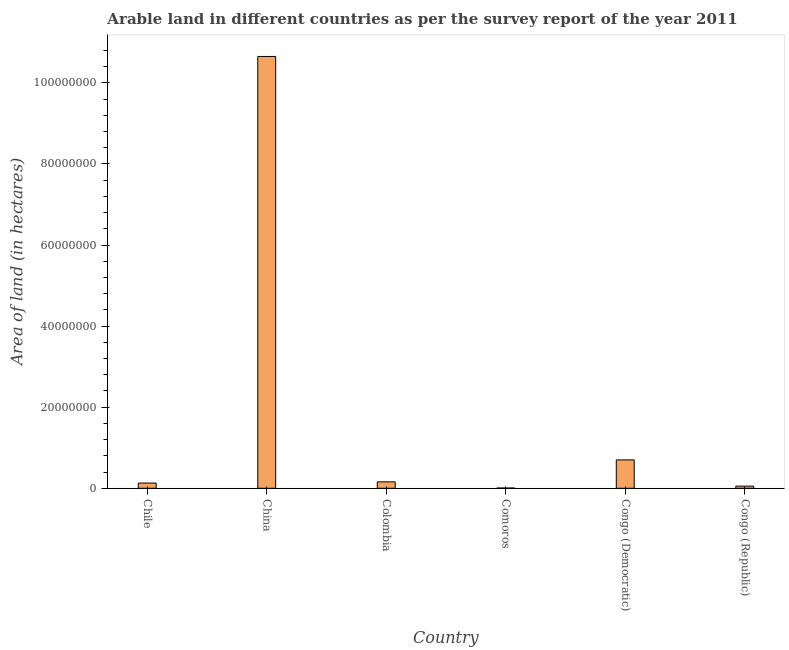Does the graph contain any zero values?
Give a very brief answer. No. What is the title of the graph?
Keep it short and to the point. Arable land in different countries as per the survey report of the year 2011. What is the label or title of the Y-axis?
Offer a very short reply. Area of land (in hectares). What is the area of land in China?
Give a very brief answer. 1.07e+08. Across all countries, what is the maximum area of land?
Offer a very short reply. 1.07e+08. Across all countries, what is the minimum area of land?
Keep it short and to the point. 6.50e+04. In which country was the area of land maximum?
Your answer should be very brief. China. In which country was the area of land minimum?
Your answer should be very brief. Comoros. What is the sum of the area of land?
Your answer should be compact. 1.17e+08. What is the difference between the area of land in Colombia and Congo (Democratic)?
Provide a short and direct response. -5.41e+06. What is the average area of land per country?
Offer a very short reply. 1.95e+07. What is the median area of land?
Ensure brevity in your answer.  1.44e+06. What is the ratio of the area of land in Chile to that in Congo (Republic)?
Your answer should be very brief. 2.43. What is the difference between the highest and the second highest area of land?
Keep it short and to the point. 9.95e+07. What is the difference between the highest and the lowest area of land?
Keep it short and to the point. 1.06e+08. In how many countries, is the area of land greater than the average area of land taken over all countries?
Offer a very short reply. 1. Are all the bars in the graph horizontal?
Offer a terse response. No. How many countries are there in the graph?
Make the answer very short. 6. Are the values on the major ticks of Y-axis written in scientific E-notation?
Make the answer very short. No. What is the Area of land (in hectares) in Chile?
Give a very brief answer. 1.29e+06. What is the Area of land (in hectares) in China?
Offer a terse response. 1.07e+08. What is the Area of land (in hectares) in Colombia?
Your response must be concise. 1.59e+06. What is the Area of land (in hectares) in Comoros?
Offer a very short reply. 6.50e+04. What is the Area of land (in hectares) in Congo (Republic)?
Your answer should be compact. 5.30e+05. What is the difference between the Area of land (in hectares) in Chile and China?
Keep it short and to the point. -1.05e+08. What is the difference between the Area of land (in hectares) in Chile and Colombia?
Your response must be concise. -2.99e+05. What is the difference between the Area of land (in hectares) in Chile and Comoros?
Ensure brevity in your answer.  1.22e+06. What is the difference between the Area of land (in hectares) in Chile and Congo (Democratic)?
Your response must be concise. -5.71e+06. What is the difference between the Area of land (in hectares) in Chile and Congo (Republic)?
Offer a terse response. 7.57e+05. What is the difference between the Area of land (in hectares) in China and Colombia?
Keep it short and to the point. 1.05e+08. What is the difference between the Area of land (in hectares) in China and Comoros?
Your response must be concise. 1.06e+08. What is the difference between the Area of land (in hectares) in China and Congo (Democratic)?
Offer a terse response. 9.95e+07. What is the difference between the Area of land (in hectares) in China and Congo (Republic)?
Provide a succinct answer. 1.06e+08. What is the difference between the Area of land (in hectares) in Colombia and Comoros?
Offer a very short reply. 1.52e+06. What is the difference between the Area of land (in hectares) in Colombia and Congo (Democratic)?
Make the answer very short. -5.41e+06. What is the difference between the Area of land (in hectares) in Colombia and Congo (Republic)?
Your answer should be very brief. 1.06e+06. What is the difference between the Area of land (in hectares) in Comoros and Congo (Democratic)?
Provide a short and direct response. -6.94e+06. What is the difference between the Area of land (in hectares) in Comoros and Congo (Republic)?
Provide a succinct answer. -4.65e+05. What is the difference between the Area of land (in hectares) in Congo (Democratic) and Congo (Republic)?
Provide a short and direct response. 6.47e+06. What is the ratio of the Area of land (in hectares) in Chile to that in China?
Offer a terse response. 0.01. What is the ratio of the Area of land (in hectares) in Chile to that in Colombia?
Provide a short and direct response. 0.81. What is the ratio of the Area of land (in hectares) in Chile to that in Comoros?
Offer a very short reply. 19.81. What is the ratio of the Area of land (in hectares) in Chile to that in Congo (Democratic)?
Your answer should be compact. 0.18. What is the ratio of the Area of land (in hectares) in Chile to that in Congo (Republic)?
Your answer should be very brief. 2.43. What is the ratio of the Area of land (in hectares) in China to that in Colombia?
Ensure brevity in your answer.  67.16. What is the ratio of the Area of land (in hectares) in China to that in Comoros?
Your answer should be compact. 1638.77. What is the ratio of the Area of land (in hectares) in China to that in Congo (Democratic)?
Offer a very short reply. 15.22. What is the ratio of the Area of land (in hectares) in China to that in Congo (Republic)?
Provide a short and direct response. 200.98. What is the ratio of the Area of land (in hectares) in Colombia to that in Comoros?
Provide a short and direct response. 24.4. What is the ratio of the Area of land (in hectares) in Colombia to that in Congo (Democratic)?
Provide a succinct answer. 0.23. What is the ratio of the Area of land (in hectares) in Colombia to that in Congo (Republic)?
Your answer should be very brief. 2.99. What is the ratio of the Area of land (in hectares) in Comoros to that in Congo (Democratic)?
Provide a succinct answer. 0.01. What is the ratio of the Area of land (in hectares) in Comoros to that in Congo (Republic)?
Your answer should be very brief. 0.12. What is the ratio of the Area of land (in hectares) in Congo (Democratic) to that in Congo (Republic)?
Offer a terse response. 13.21. 